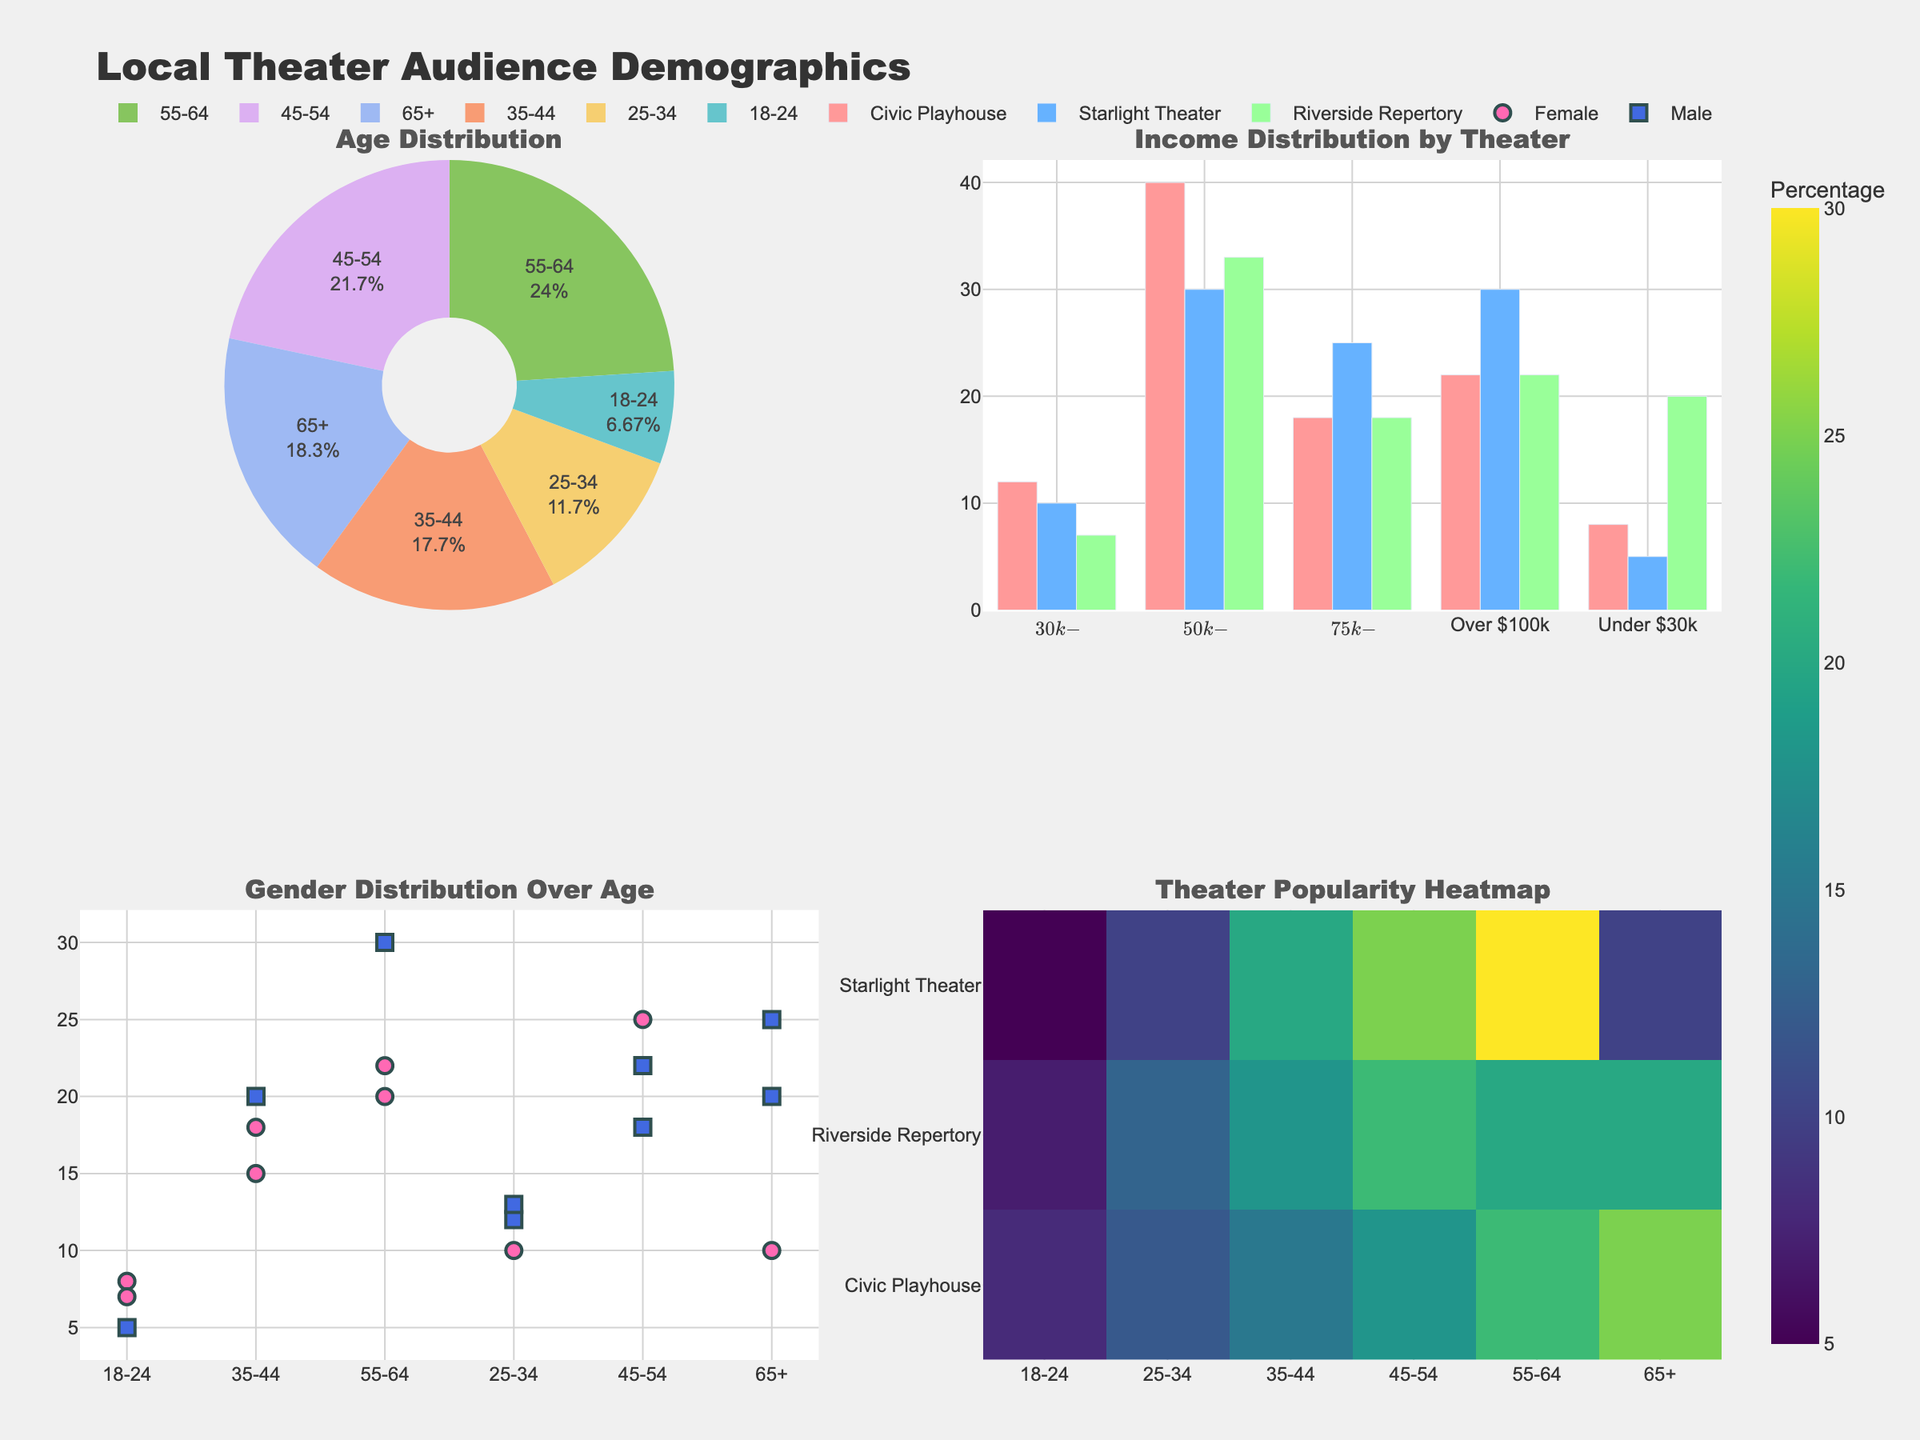What's the title of the figure? The title is displayed at the top of the figure in large text. It reads "Local Theater Audience Demographics".
Answer: Local Theater Audience Demographics Which age group has the highest percentage in the pie chart? The largest slice in the pie chart, colored uniquely, represents the age group '65+', indicating that this group has the highest percentage.
Answer: 65+ Compare the income distribution for 'Starlight Theater' and 'Civic Playhouse' in the bar chart. Which income bracket percentage is higher in Starlight Theater than in Civic Playhouse? By comparing the bar heights for each income bracket, 'Starlight Theater' has higher percentages in the '$50k-$75k' and 'Over $100k' brackets than 'Civic Playhouse'.
Answer: $50k-$75k, Over $100k Which gender shows the greatest attendance in the '55-64' age group based on the scatter plot? Looking at the scatter plot, the '55-64' age group has a higher marker for 'Female' than 'Male', indicating greater attendance by females.
Answer: Female What theater is the most popular among the '45-54' age group based on the heatmap? The heatmap shows intensity for percentage values. The 'Riverside Repertory' has the highest intensity for the '45-54' age group.
Answer: Riverside Repertory What is the total percentage of the 'Male' audience across all age groups in the scatter plot? Add the percentages for 'Male' from each age group: 12 (25-34) + 18 (45-54) + 25 (65+) + 5 (18-24) + 20 (35-44) + 22 (45-54) = 102%.
Answer: 102% In terms of income distribution by theater, which theater has the lowest percentage in the 'Under $30k' category, according to the bar chart? The smallest bar height for 'Under $30k' is for the 'Starlight Theater'.
Answer: Starlight Theater Compare the '18-24' attendance percentage between 'Civic Playhouse' and 'Riverside Repertory'. Which one has a higher percentage and by how much? The attendance for '18-24' at 'Civic Playhouse' is 8%, while at 'Riverside Repertory' it is 7%. The difference is 8% - 7% = 1%.
Answer: Civic Playhouse, by 1% What is the overall trend in gender distribution over age groups as seen in the scatter plot? By looking at the scatter plot, females tend to have higher attendance percentages in the older age groups compared to males.
Answer: Females have higher attendance in older age groups 